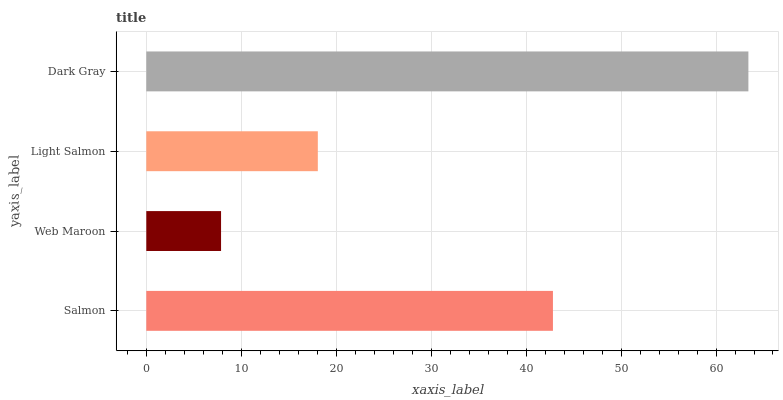Is Web Maroon the minimum?
Answer yes or no. Yes. Is Dark Gray the maximum?
Answer yes or no. Yes. Is Light Salmon the minimum?
Answer yes or no. No. Is Light Salmon the maximum?
Answer yes or no. No. Is Light Salmon greater than Web Maroon?
Answer yes or no. Yes. Is Web Maroon less than Light Salmon?
Answer yes or no. Yes. Is Web Maroon greater than Light Salmon?
Answer yes or no. No. Is Light Salmon less than Web Maroon?
Answer yes or no. No. Is Salmon the high median?
Answer yes or no. Yes. Is Light Salmon the low median?
Answer yes or no. Yes. Is Web Maroon the high median?
Answer yes or no. No. Is Dark Gray the low median?
Answer yes or no. No. 